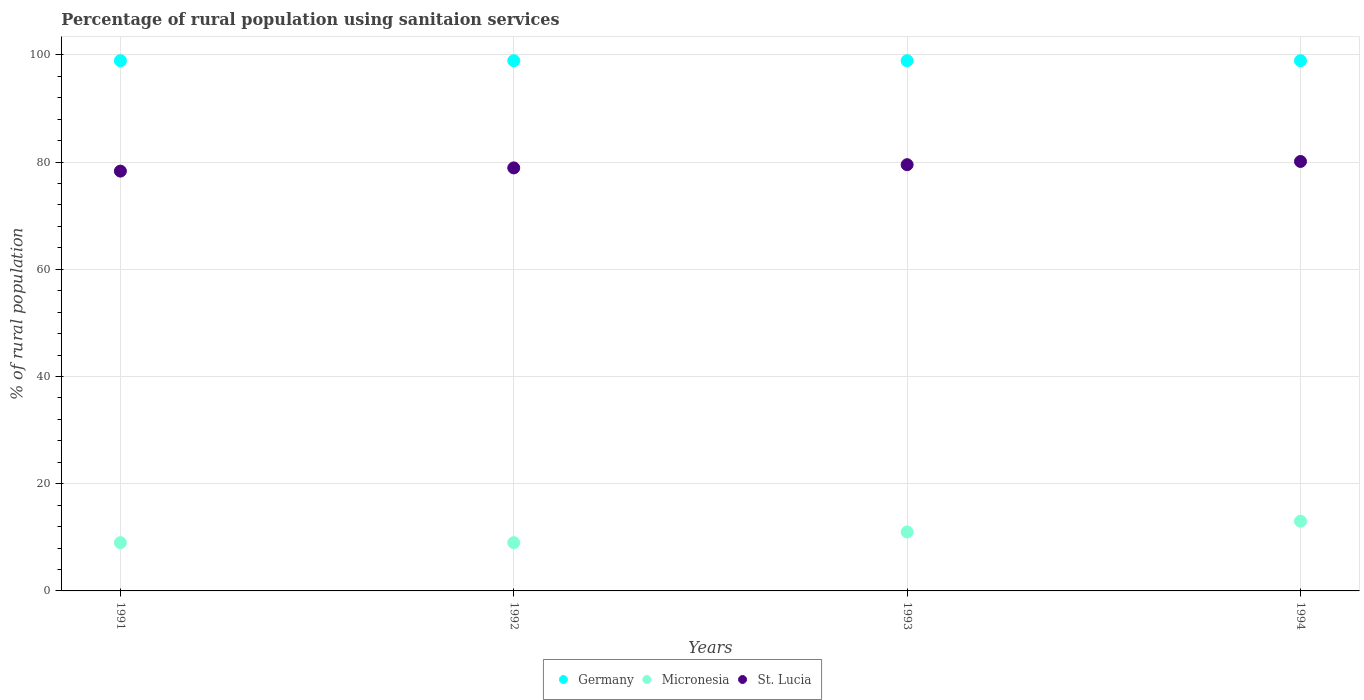How many different coloured dotlines are there?
Make the answer very short. 3. Is the number of dotlines equal to the number of legend labels?
Offer a very short reply. Yes. What is the percentage of rural population using sanitaion services in Micronesia in 1992?
Your answer should be very brief. 9. Across all years, what is the maximum percentage of rural population using sanitaion services in St. Lucia?
Offer a terse response. 80.1. Across all years, what is the minimum percentage of rural population using sanitaion services in St. Lucia?
Your answer should be very brief. 78.3. In which year was the percentage of rural population using sanitaion services in Micronesia maximum?
Your answer should be very brief. 1994. In which year was the percentage of rural population using sanitaion services in Micronesia minimum?
Make the answer very short. 1991. What is the total percentage of rural population using sanitaion services in Micronesia in the graph?
Offer a very short reply. 42. What is the difference between the percentage of rural population using sanitaion services in Micronesia in 1991 and the percentage of rural population using sanitaion services in St. Lucia in 1992?
Your response must be concise. -69.9. What is the average percentage of rural population using sanitaion services in St. Lucia per year?
Provide a short and direct response. 79.2. In the year 1994, what is the difference between the percentage of rural population using sanitaion services in Germany and percentage of rural population using sanitaion services in Micronesia?
Keep it short and to the point. 85.9. Is the percentage of rural population using sanitaion services in Germany in 1993 less than that in 1994?
Your response must be concise. No. What is the difference between the highest and the lowest percentage of rural population using sanitaion services in Micronesia?
Provide a succinct answer. 4. Is it the case that in every year, the sum of the percentage of rural population using sanitaion services in Germany and percentage of rural population using sanitaion services in St. Lucia  is greater than the percentage of rural population using sanitaion services in Micronesia?
Your answer should be compact. Yes. Does the percentage of rural population using sanitaion services in Germany monotonically increase over the years?
Your response must be concise. No. Is the percentage of rural population using sanitaion services in Micronesia strictly less than the percentage of rural population using sanitaion services in St. Lucia over the years?
Give a very brief answer. Yes. Are the values on the major ticks of Y-axis written in scientific E-notation?
Make the answer very short. No. Does the graph contain grids?
Provide a short and direct response. Yes. Where does the legend appear in the graph?
Your answer should be compact. Bottom center. How are the legend labels stacked?
Make the answer very short. Horizontal. What is the title of the graph?
Provide a short and direct response. Percentage of rural population using sanitaion services. What is the label or title of the X-axis?
Offer a terse response. Years. What is the label or title of the Y-axis?
Give a very brief answer. % of rural population. What is the % of rural population in Germany in 1991?
Your answer should be compact. 98.9. What is the % of rural population in Micronesia in 1991?
Offer a terse response. 9. What is the % of rural population in St. Lucia in 1991?
Your answer should be compact. 78.3. What is the % of rural population of Germany in 1992?
Offer a terse response. 98.9. What is the % of rural population of St. Lucia in 1992?
Offer a terse response. 78.9. What is the % of rural population of Germany in 1993?
Make the answer very short. 98.9. What is the % of rural population in Micronesia in 1993?
Ensure brevity in your answer.  11. What is the % of rural population of St. Lucia in 1993?
Provide a succinct answer. 79.5. What is the % of rural population in Germany in 1994?
Provide a short and direct response. 98.9. What is the % of rural population in Micronesia in 1994?
Offer a very short reply. 13. What is the % of rural population in St. Lucia in 1994?
Ensure brevity in your answer.  80.1. Across all years, what is the maximum % of rural population in Germany?
Your answer should be very brief. 98.9. Across all years, what is the maximum % of rural population of St. Lucia?
Provide a short and direct response. 80.1. Across all years, what is the minimum % of rural population in Germany?
Offer a terse response. 98.9. Across all years, what is the minimum % of rural population of St. Lucia?
Offer a very short reply. 78.3. What is the total % of rural population of Germany in the graph?
Offer a terse response. 395.6. What is the total % of rural population of St. Lucia in the graph?
Your answer should be very brief. 316.8. What is the difference between the % of rural population of Micronesia in 1991 and that in 1993?
Make the answer very short. -2. What is the difference between the % of rural population of St. Lucia in 1991 and that in 1993?
Your answer should be compact. -1.2. What is the difference between the % of rural population of Micronesia in 1991 and that in 1994?
Make the answer very short. -4. What is the difference between the % of rural population in Germany in 1992 and that in 1993?
Provide a succinct answer. 0. What is the difference between the % of rural population of Micronesia in 1992 and that in 1993?
Your response must be concise. -2. What is the difference between the % of rural population in St. Lucia in 1992 and that in 1993?
Ensure brevity in your answer.  -0.6. What is the difference between the % of rural population in Germany in 1992 and that in 1994?
Ensure brevity in your answer.  0. What is the difference between the % of rural population of Germany in 1993 and that in 1994?
Your response must be concise. 0. What is the difference between the % of rural population of Micronesia in 1993 and that in 1994?
Offer a terse response. -2. What is the difference between the % of rural population of St. Lucia in 1993 and that in 1994?
Offer a very short reply. -0.6. What is the difference between the % of rural population in Germany in 1991 and the % of rural population in Micronesia in 1992?
Your answer should be compact. 89.9. What is the difference between the % of rural population of Germany in 1991 and the % of rural population of St. Lucia in 1992?
Give a very brief answer. 20. What is the difference between the % of rural population in Micronesia in 1991 and the % of rural population in St. Lucia in 1992?
Offer a very short reply. -69.9. What is the difference between the % of rural population of Germany in 1991 and the % of rural population of Micronesia in 1993?
Your answer should be very brief. 87.9. What is the difference between the % of rural population in Germany in 1991 and the % of rural population in St. Lucia in 1993?
Your answer should be very brief. 19.4. What is the difference between the % of rural population of Micronesia in 1991 and the % of rural population of St. Lucia in 1993?
Ensure brevity in your answer.  -70.5. What is the difference between the % of rural population in Germany in 1991 and the % of rural population in Micronesia in 1994?
Give a very brief answer. 85.9. What is the difference between the % of rural population of Micronesia in 1991 and the % of rural population of St. Lucia in 1994?
Make the answer very short. -71.1. What is the difference between the % of rural population of Germany in 1992 and the % of rural population of Micronesia in 1993?
Make the answer very short. 87.9. What is the difference between the % of rural population of Micronesia in 1992 and the % of rural population of St. Lucia in 1993?
Your answer should be very brief. -70.5. What is the difference between the % of rural population of Germany in 1992 and the % of rural population of Micronesia in 1994?
Offer a terse response. 85.9. What is the difference between the % of rural population in Germany in 1992 and the % of rural population in St. Lucia in 1994?
Your answer should be compact. 18.8. What is the difference between the % of rural population of Micronesia in 1992 and the % of rural population of St. Lucia in 1994?
Provide a succinct answer. -71.1. What is the difference between the % of rural population in Germany in 1993 and the % of rural population in Micronesia in 1994?
Offer a very short reply. 85.9. What is the difference between the % of rural population in Germany in 1993 and the % of rural population in St. Lucia in 1994?
Ensure brevity in your answer.  18.8. What is the difference between the % of rural population of Micronesia in 1993 and the % of rural population of St. Lucia in 1994?
Offer a very short reply. -69.1. What is the average % of rural population of Germany per year?
Your answer should be very brief. 98.9. What is the average % of rural population in St. Lucia per year?
Give a very brief answer. 79.2. In the year 1991, what is the difference between the % of rural population in Germany and % of rural population in Micronesia?
Your response must be concise. 89.9. In the year 1991, what is the difference between the % of rural population of Germany and % of rural population of St. Lucia?
Ensure brevity in your answer.  20.6. In the year 1991, what is the difference between the % of rural population of Micronesia and % of rural population of St. Lucia?
Offer a very short reply. -69.3. In the year 1992, what is the difference between the % of rural population in Germany and % of rural population in Micronesia?
Your answer should be very brief. 89.9. In the year 1992, what is the difference between the % of rural population of Germany and % of rural population of St. Lucia?
Make the answer very short. 20. In the year 1992, what is the difference between the % of rural population of Micronesia and % of rural population of St. Lucia?
Offer a terse response. -69.9. In the year 1993, what is the difference between the % of rural population in Germany and % of rural population in Micronesia?
Provide a succinct answer. 87.9. In the year 1993, what is the difference between the % of rural population of Micronesia and % of rural population of St. Lucia?
Your answer should be compact. -68.5. In the year 1994, what is the difference between the % of rural population in Germany and % of rural population in Micronesia?
Provide a succinct answer. 85.9. In the year 1994, what is the difference between the % of rural population of Micronesia and % of rural population of St. Lucia?
Keep it short and to the point. -67.1. What is the ratio of the % of rural population of Germany in 1991 to that in 1992?
Make the answer very short. 1. What is the ratio of the % of rural population of Micronesia in 1991 to that in 1993?
Offer a very short reply. 0.82. What is the ratio of the % of rural population in St. Lucia in 1991 to that in 1993?
Keep it short and to the point. 0.98. What is the ratio of the % of rural population in Micronesia in 1991 to that in 1994?
Offer a terse response. 0.69. What is the ratio of the % of rural population in St. Lucia in 1991 to that in 1994?
Make the answer very short. 0.98. What is the ratio of the % of rural population in Germany in 1992 to that in 1993?
Offer a very short reply. 1. What is the ratio of the % of rural population of Micronesia in 1992 to that in 1993?
Your response must be concise. 0.82. What is the ratio of the % of rural population of St. Lucia in 1992 to that in 1993?
Provide a short and direct response. 0.99. What is the ratio of the % of rural population of Micronesia in 1992 to that in 1994?
Your answer should be compact. 0.69. What is the ratio of the % of rural population in St. Lucia in 1992 to that in 1994?
Offer a terse response. 0.98. What is the ratio of the % of rural population of Micronesia in 1993 to that in 1994?
Provide a short and direct response. 0.85. What is the ratio of the % of rural population of St. Lucia in 1993 to that in 1994?
Your answer should be very brief. 0.99. What is the difference between the highest and the second highest % of rural population in Micronesia?
Provide a short and direct response. 2. What is the difference between the highest and the lowest % of rural population of Germany?
Offer a very short reply. 0. What is the difference between the highest and the lowest % of rural population of St. Lucia?
Make the answer very short. 1.8. 